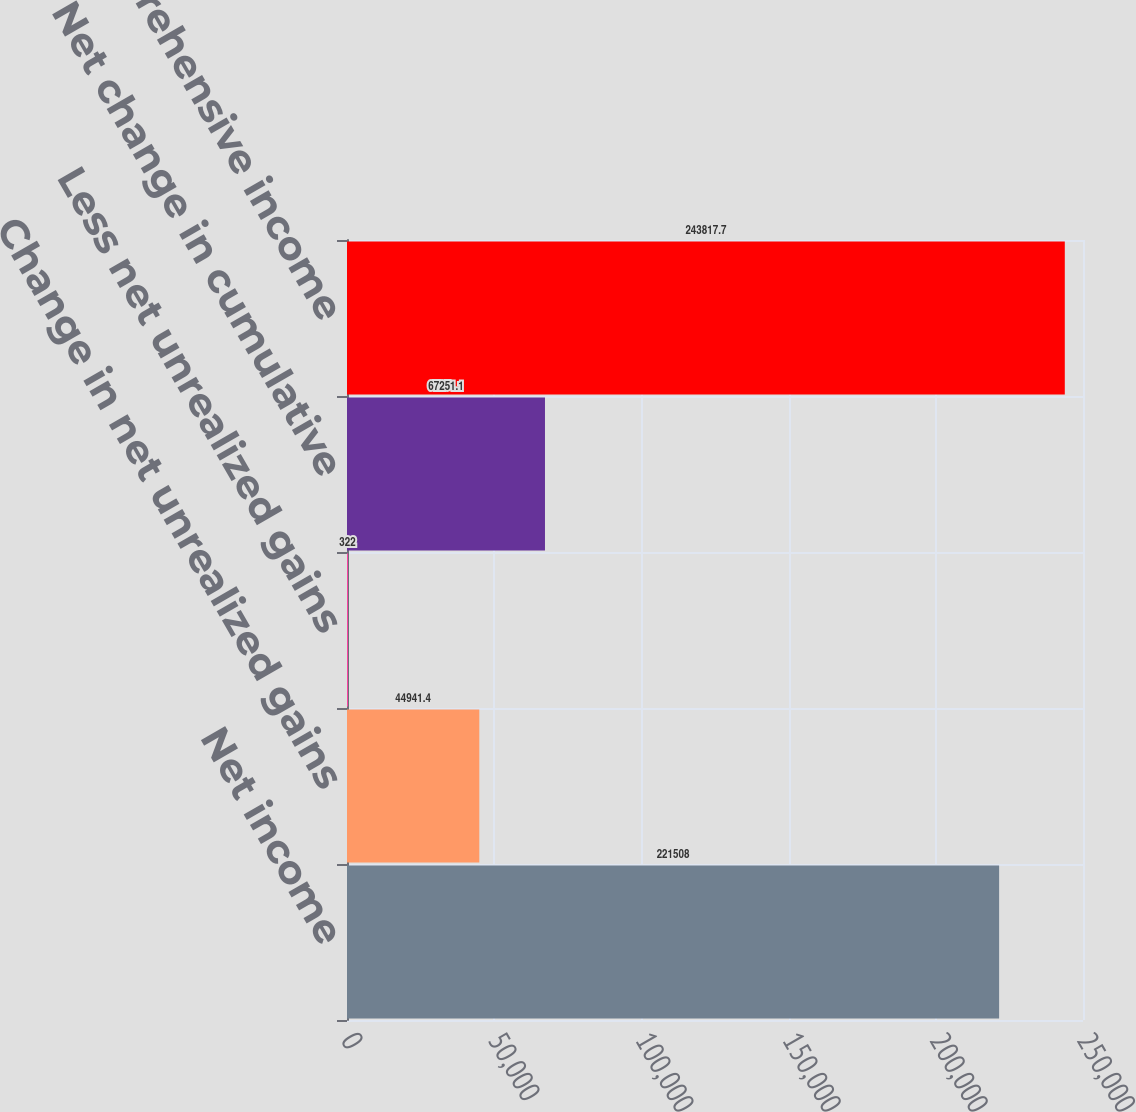Convert chart. <chart><loc_0><loc_0><loc_500><loc_500><bar_chart><fcel>Net income<fcel>Change in net unrealized gains<fcel>Less net unrealized gains<fcel>Net change in cumulative<fcel>Comprehensive income<nl><fcel>221508<fcel>44941.4<fcel>322<fcel>67251.1<fcel>243818<nl></chart> 